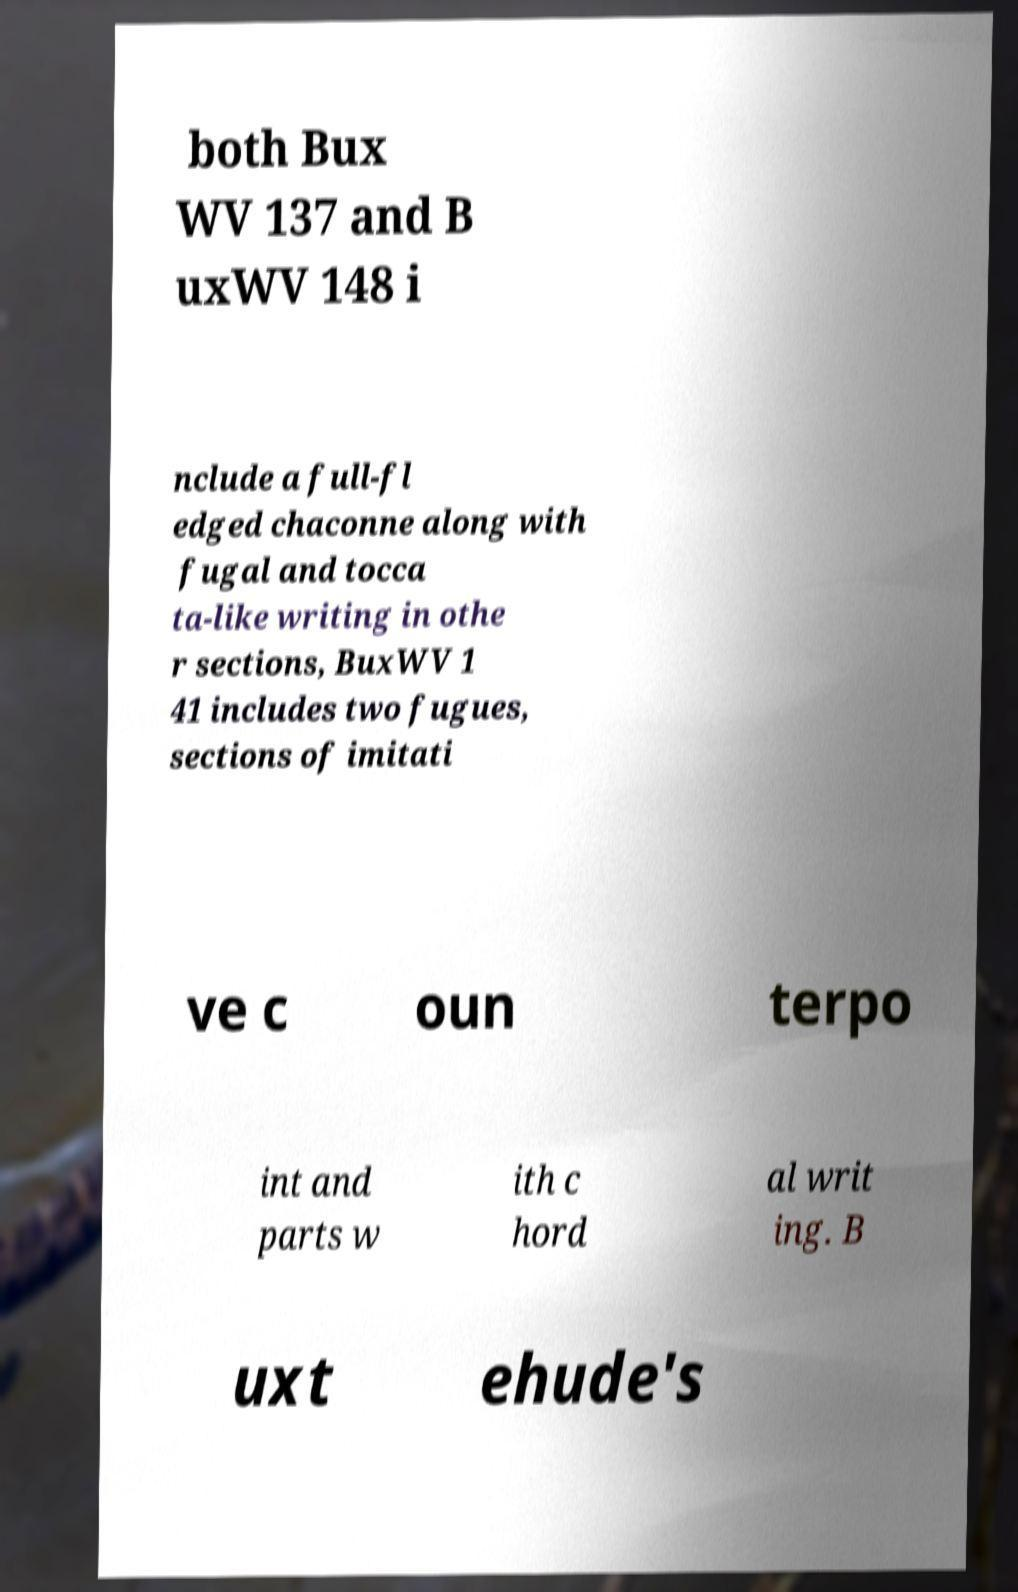There's text embedded in this image that I need extracted. Can you transcribe it verbatim? both Bux WV 137 and B uxWV 148 i nclude a full-fl edged chaconne along with fugal and tocca ta-like writing in othe r sections, BuxWV 1 41 includes two fugues, sections of imitati ve c oun terpo int and parts w ith c hord al writ ing. B uxt ehude's 